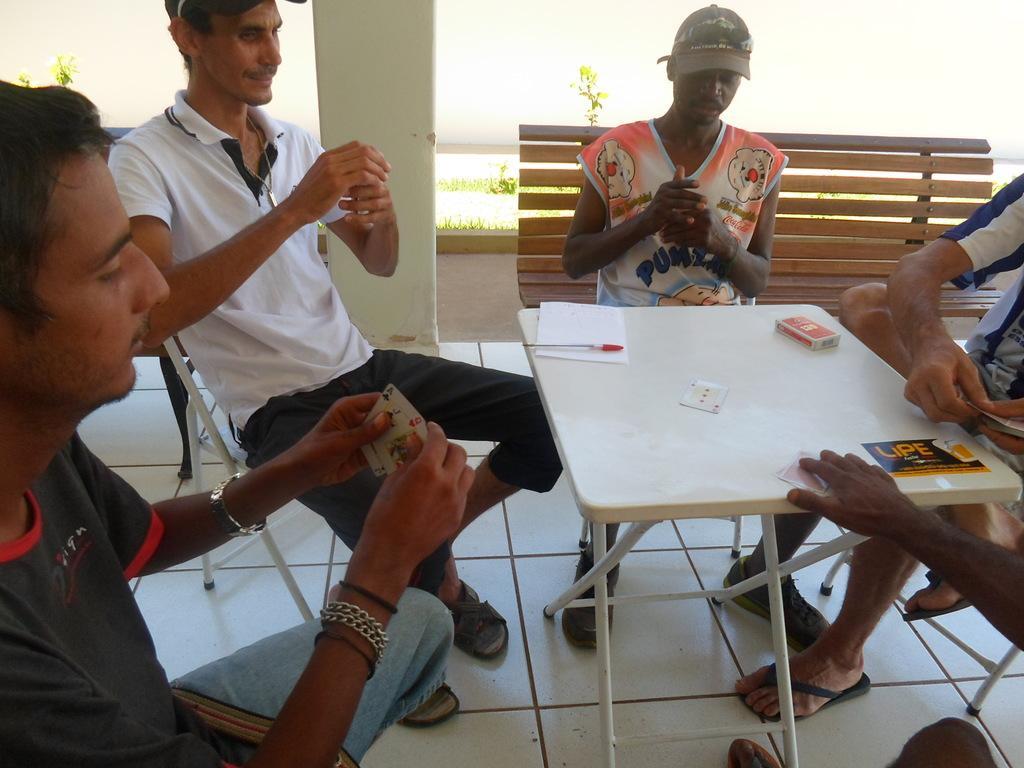How would you summarize this image in a sentence or two? In this picture there is a table on the right side of the image and there are people those who are sitting around the table, they are playing the game. 